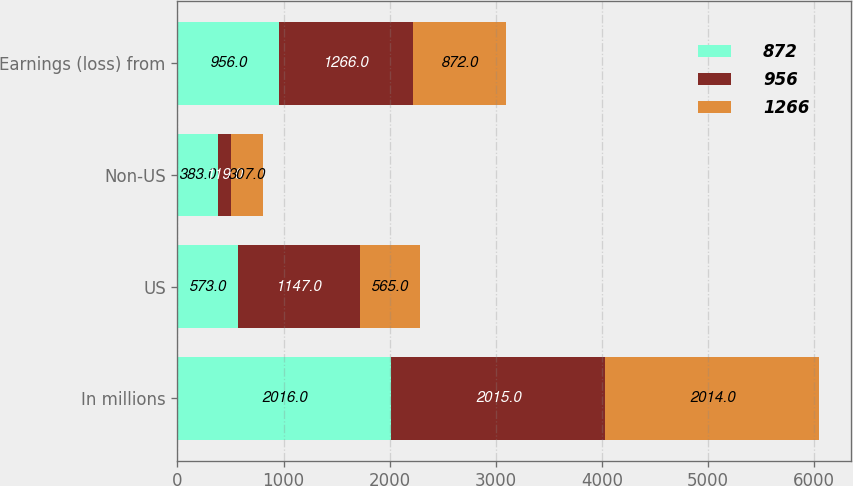Convert chart to OTSL. <chart><loc_0><loc_0><loc_500><loc_500><stacked_bar_chart><ecel><fcel>In millions<fcel>US<fcel>Non-US<fcel>Earnings (loss) from<nl><fcel>872<fcel>2016<fcel>573<fcel>383<fcel>956<nl><fcel>956<fcel>2015<fcel>1147<fcel>119<fcel>1266<nl><fcel>1266<fcel>2014<fcel>565<fcel>307<fcel>872<nl></chart> 